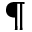<formula> <loc_0><loc_0><loc_500><loc_500>^ { \ } m a t h p a r a g r a p h</formula> 